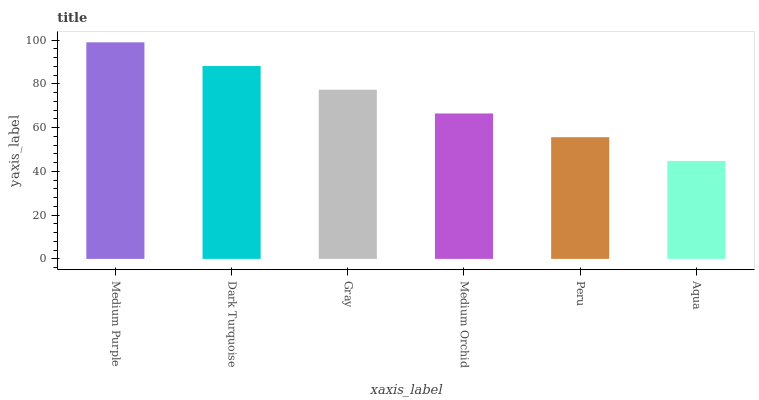Is Aqua the minimum?
Answer yes or no. Yes. Is Medium Purple the maximum?
Answer yes or no. Yes. Is Dark Turquoise the minimum?
Answer yes or no. No. Is Dark Turquoise the maximum?
Answer yes or no. No. Is Medium Purple greater than Dark Turquoise?
Answer yes or no. Yes. Is Dark Turquoise less than Medium Purple?
Answer yes or no. Yes. Is Dark Turquoise greater than Medium Purple?
Answer yes or no. No. Is Medium Purple less than Dark Turquoise?
Answer yes or no. No. Is Gray the high median?
Answer yes or no. Yes. Is Medium Orchid the low median?
Answer yes or no. Yes. Is Dark Turquoise the high median?
Answer yes or no. No. Is Medium Purple the low median?
Answer yes or no. No. 